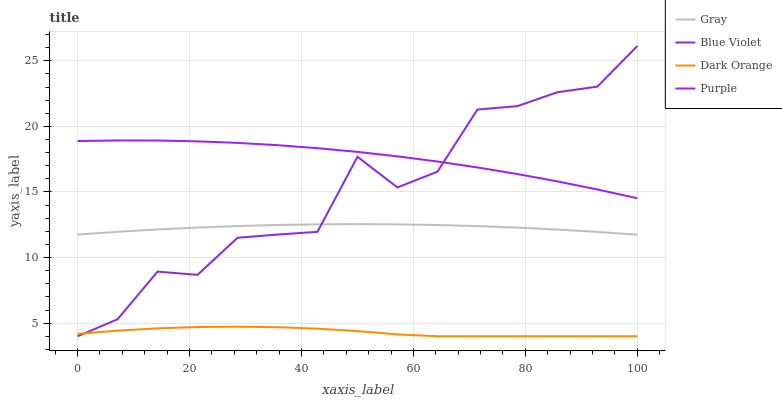Does Dark Orange have the minimum area under the curve?
Answer yes or no. Yes. Does Purple have the maximum area under the curve?
Answer yes or no. Yes. Does Gray have the minimum area under the curve?
Answer yes or no. No. Does Gray have the maximum area under the curve?
Answer yes or no. No. Is Gray the smoothest?
Answer yes or no. Yes. Is Blue Violet the roughest?
Answer yes or no. Yes. Is Blue Violet the smoothest?
Answer yes or no. No. Is Gray the roughest?
Answer yes or no. No. Does Blue Violet have the lowest value?
Answer yes or no. Yes. Does Gray have the lowest value?
Answer yes or no. No. Does Blue Violet have the highest value?
Answer yes or no. Yes. Does Gray have the highest value?
Answer yes or no. No. Is Dark Orange less than Gray?
Answer yes or no. Yes. Is Purple greater than Gray?
Answer yes or no. Yes. Does Blue Violet intersect Gray?
Answer yes or no. Yes. Is Blue Violet less than Gray?
Answer yes or no. No. Is Blue Violet greater than Gray?
Answer yes or no. No. Does Dark Orange intersect Gray?
Answer yes or no. No. 